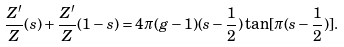<formula> <loc_0><loc_0><loc_500><loc_500>\frac { Z ^ { \prime } } { Z } ( s ) + \frac { Z ^ { \prime } } { Z } ( 1 - s ) = 4 \pi ( g - 1 ) ( s - \frac { 1 } { 2 } ) \tan [ \pi ( s - \frac { 1 } { 2 } ) ] .</formula> 